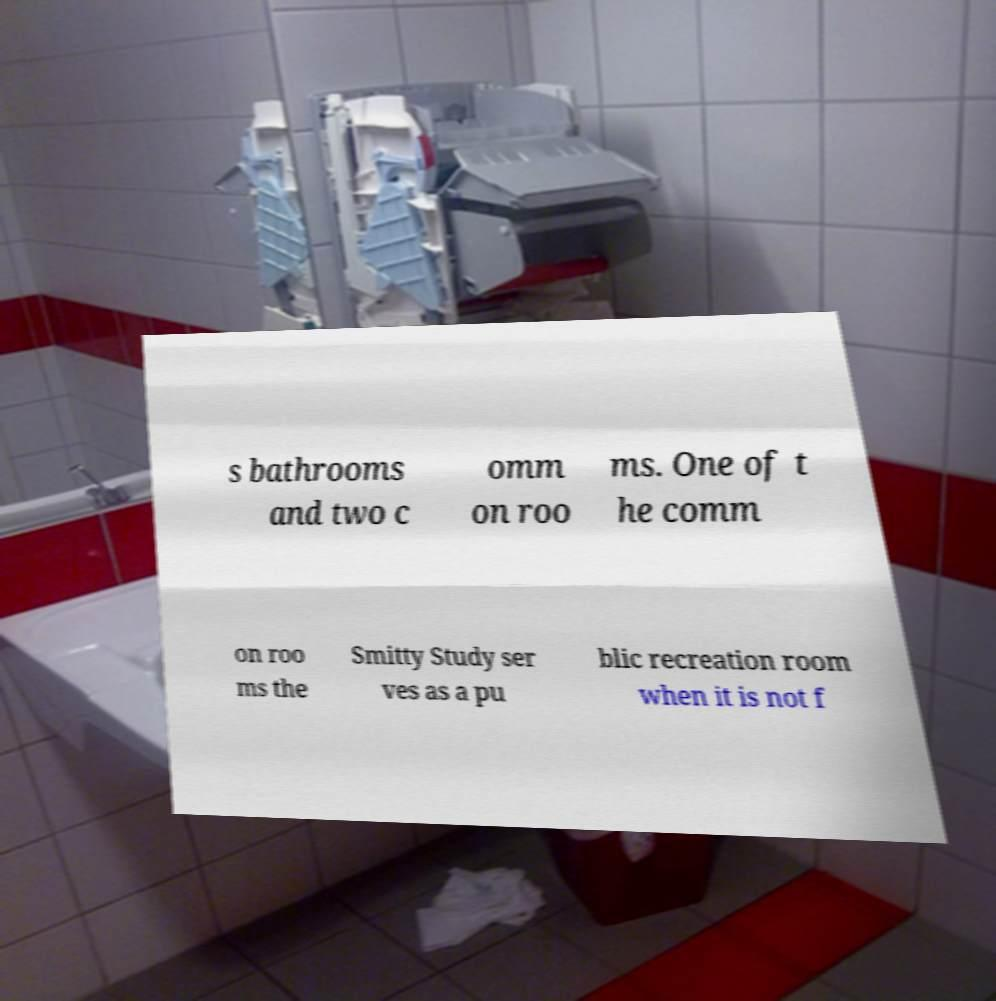I need the written content from this picture converted into text. Can you do that? s bathrooms and two c omm on roo ms. One of t he comm on roo ms the Smitty Study ser ves as a pu blic recreation room when it is not f 